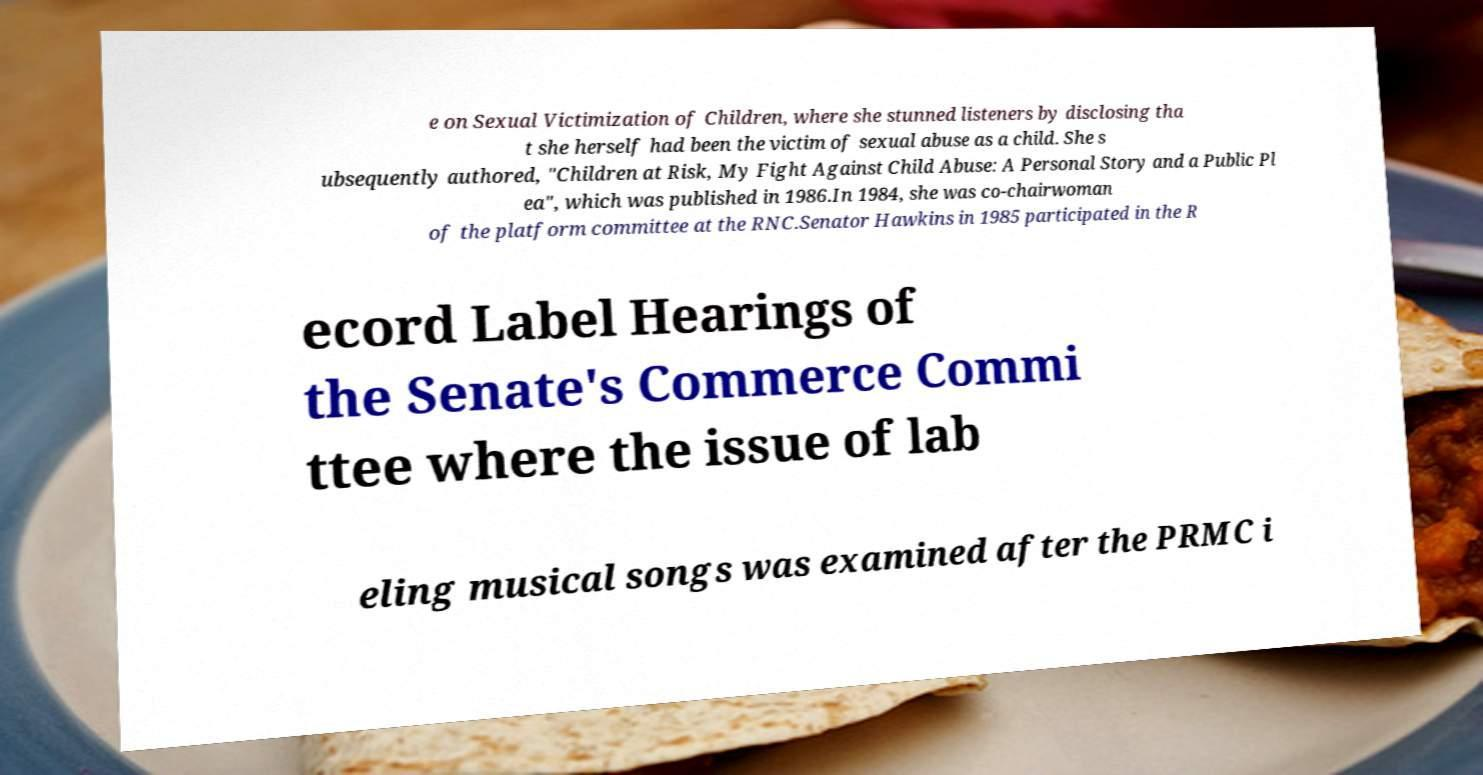For documentation purposes, I need the text within this image transcribed. Could you provide that? e on Sexual Victimization of Children, where she stunned listeners by disclosing tha t she herself had been the victim of sexual abuse as a child. She s ubsequently authored, "Children at Risk, My Fight Against Child Abuse: A Personal Story and a Public Pl ea", which was published in 1986.In 1984, she was co-chairwoman of the platform committee at the RNC.Senator Hawkins in 1985 participated in the R ecord Label Hearings of the Senate's Commerce Commi ttee where the issue of lab eling musical songs was examined after the PRMC i 